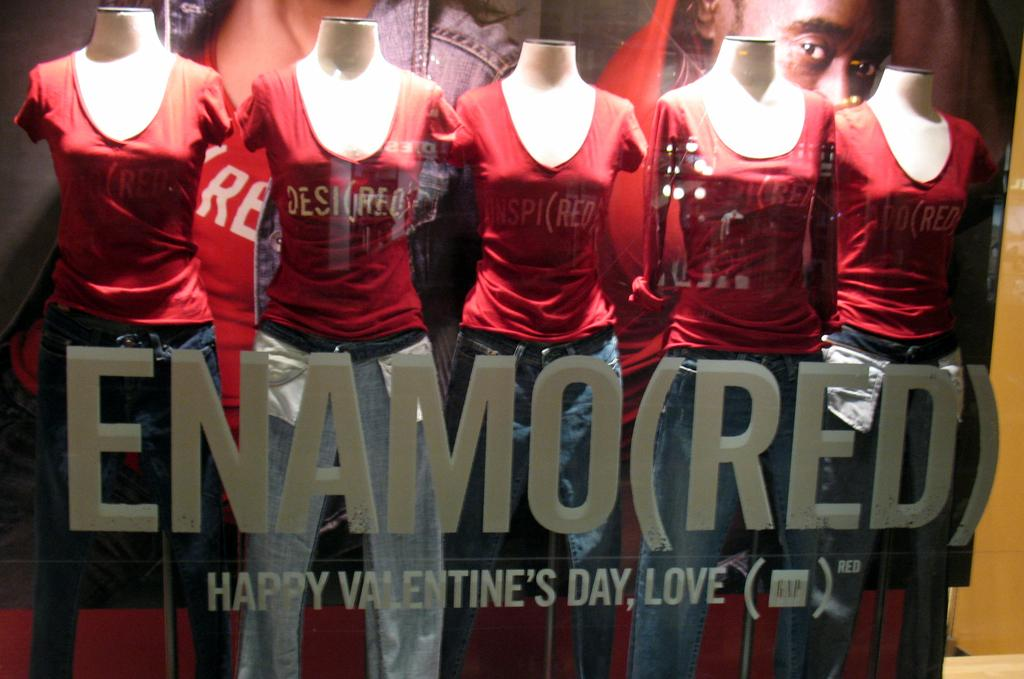<image>
Offer a succinct explanation of the picture presented. The window display wishes everyone a happy valentines day. 